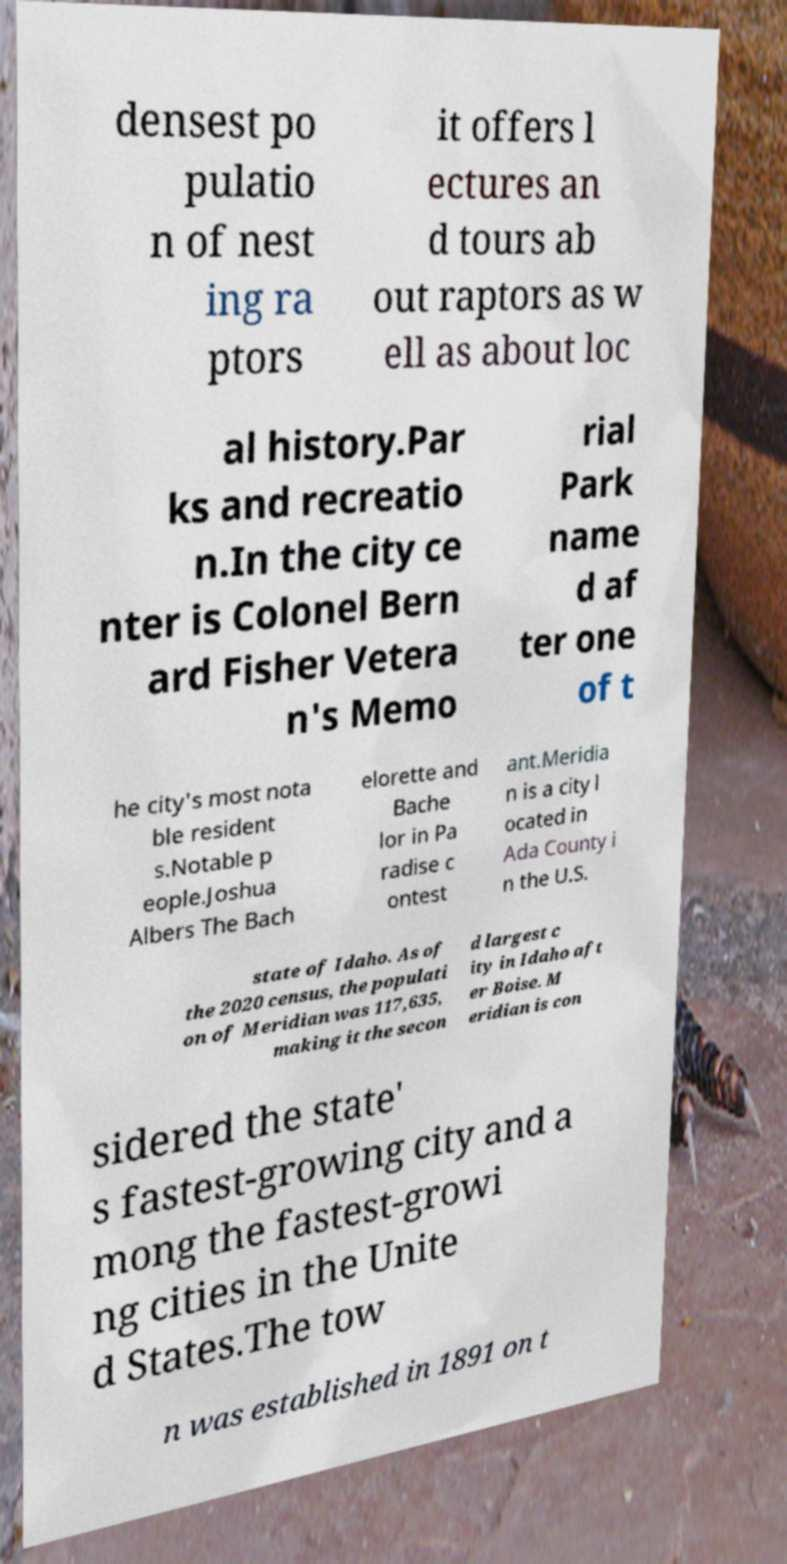What messages or text are displayed in this image? I need them in a readable, typed format. densest po pulatio n of nest ing ra ptors it offers l ectures an d tours ab out raptors as w ell as about loc al history.Par ks and recreatio n.In the city ce nter is Colonel Bern ard Fisher Vetera n's Memo rial Park name d af ter one of t he city's most nota ble resident s.Notable p eople.Joshua Albers The Bach elorette and Bache lor in Pa radise c ontest ant.Meridia n is a city l ocated in Ada County i n the U.S. state of Idaho. As of the 2020 census, the populati on of Meridian was 117,635, making it the secon d largest c ity in Idaho aft er Boise. M eridian is con sidered the state' s fastest-growing city and a mong the fastest-growi ng cities in the Unite d States.The tow n was established in 1891 on t 